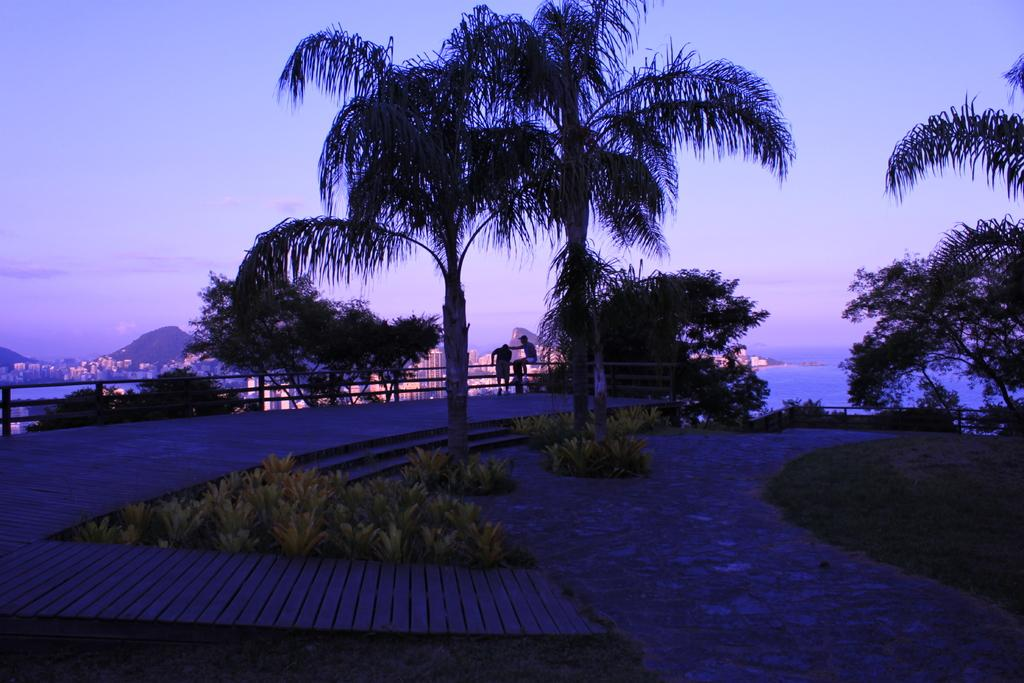What type of natural elements can be seen in the image? There are trees and plants in the image. What is the man standing in the image doing? There is no specific action mentioned for the standing man, but he is present in the image. What is the seated man doing in the image? The seated man is sitting on a metal fence in the image. What type of structures can be seen in the image? There are buildings visible in the image. What type of water feature can be seen in the image? There is water visible in the image. What is the weather like in the image? The sky is cloudy in the image. What type of toy can be seen in the yard during the week in the image? There is no toy, yard, or week mentioned in the image. The image features trees, plants, two men, buildings, water, and a cloudy sky. 